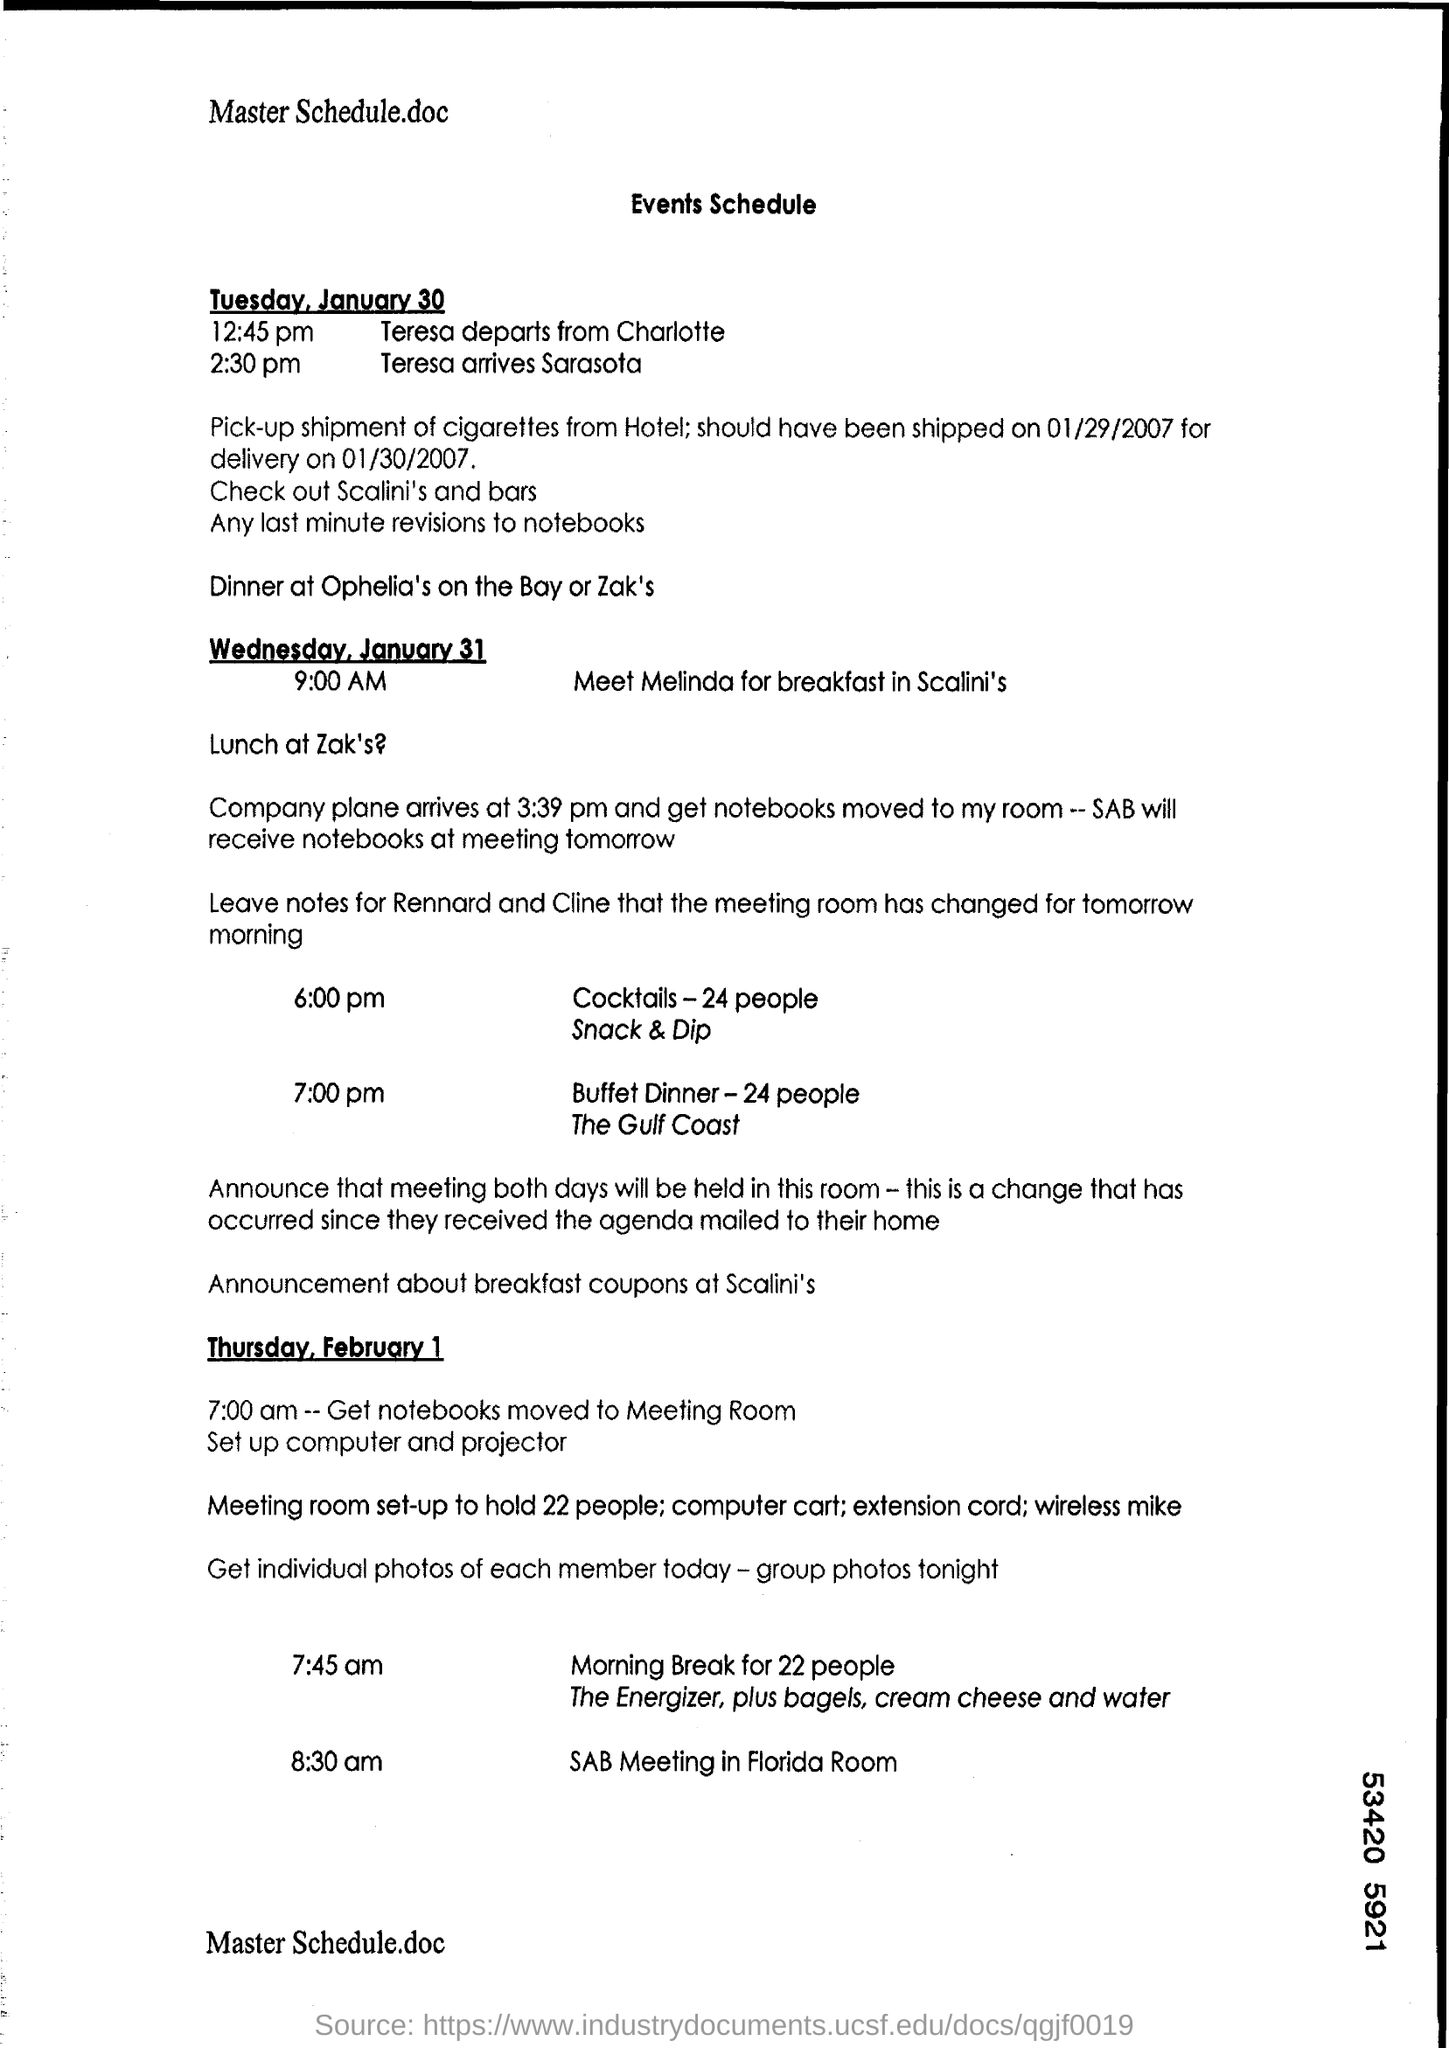Indicate a few pertinent items in this graphic. Teresa is expected to arrive in Sarasota at 2:30 pm. 